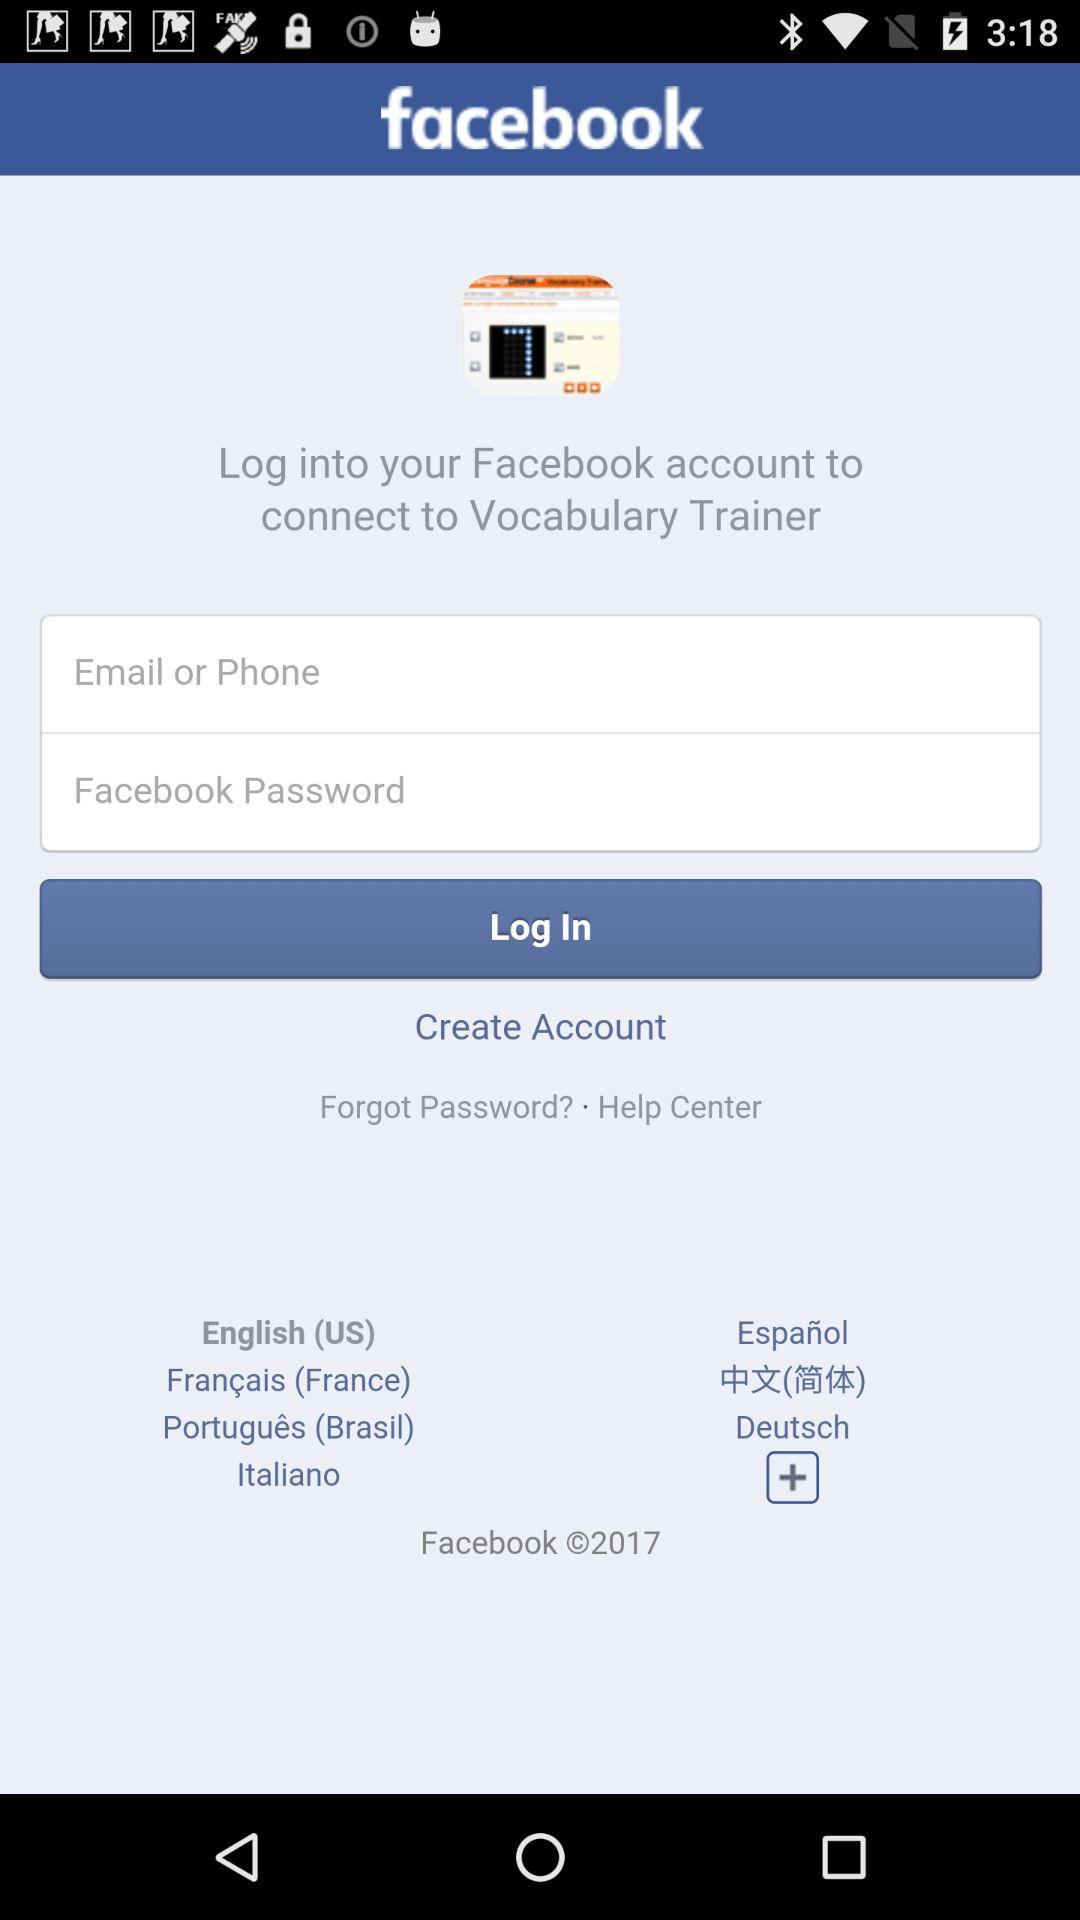What applications can be used to log in to the profile? The application that can be used to log in to the profile is "facebook". 